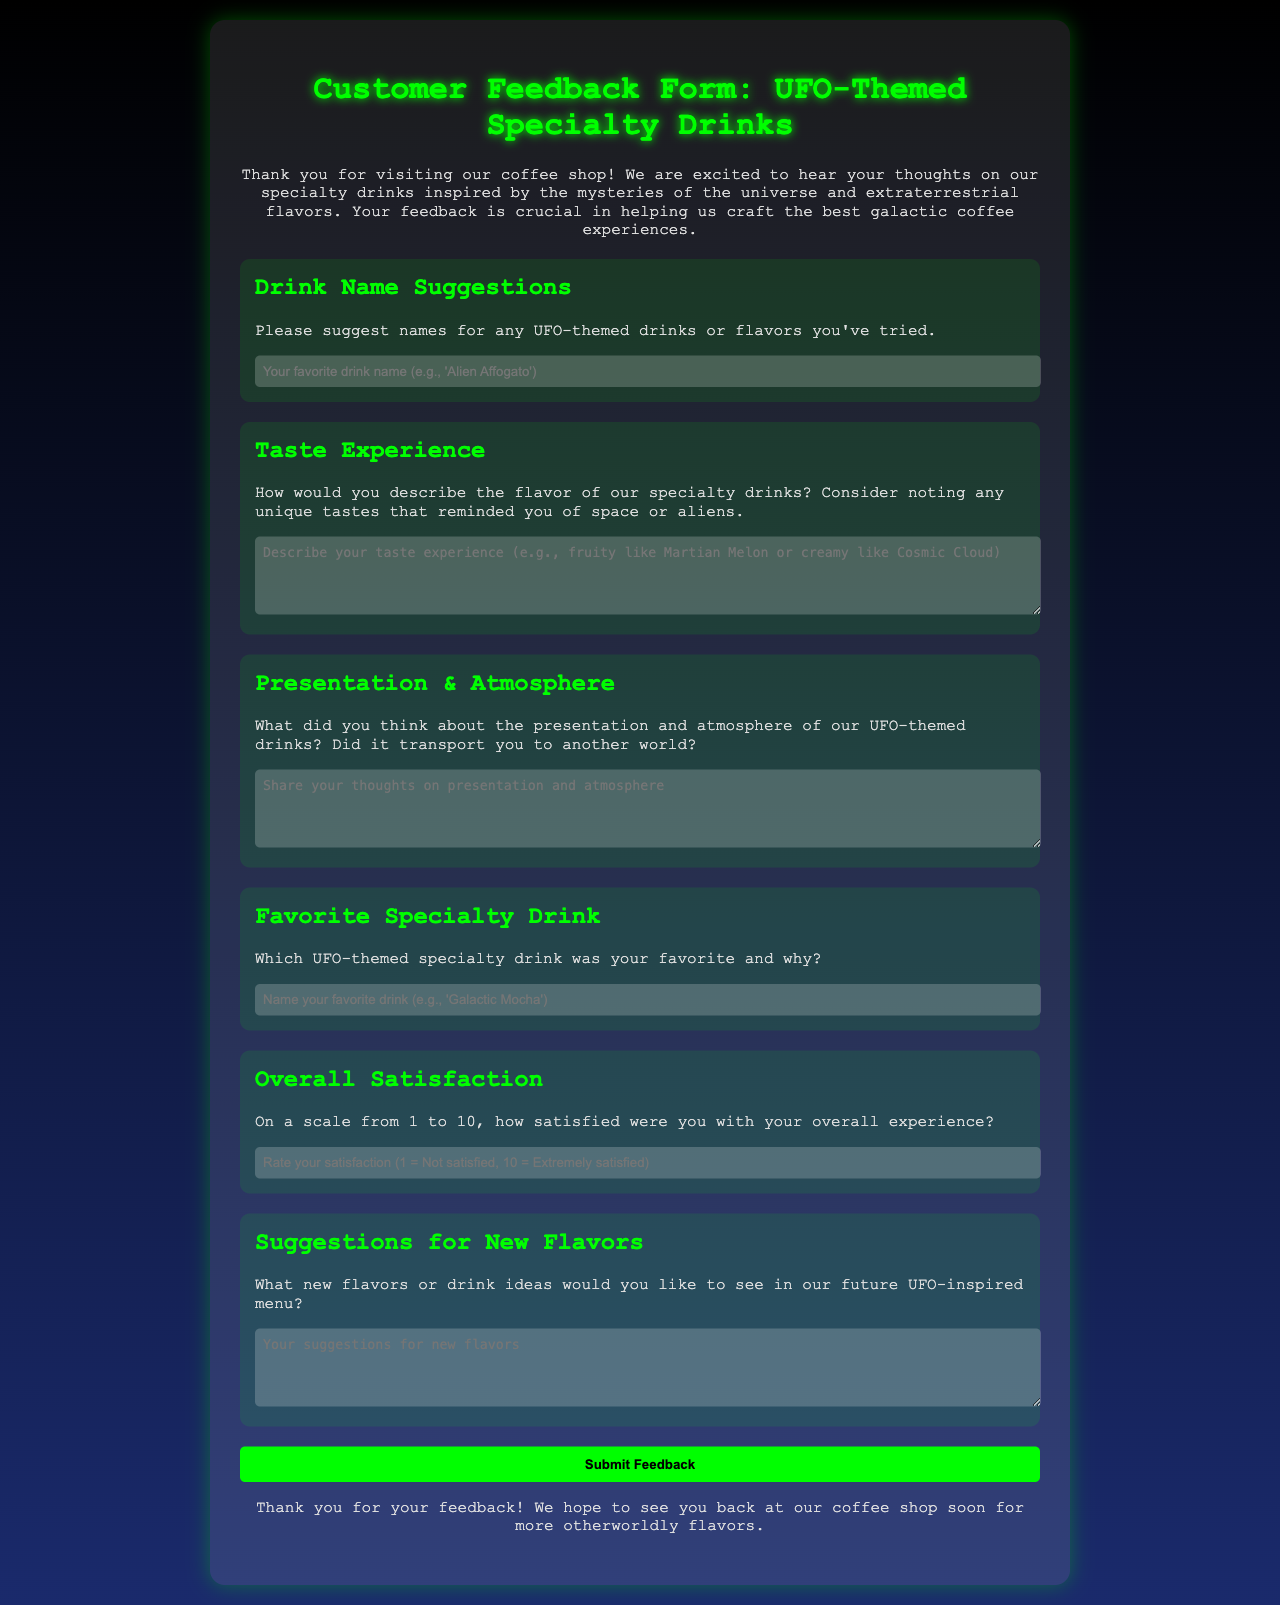what is the title of the feedback form? The title is prominently displayed at the top of the document, indicating the purpose of the form.
Answer: Customer Feedback Form: UFO-Themed Specialty Drinks what does the introduction thank customers for? The introduction expresses gratitude for customers visiting the coffee shop and encourages their feedback.
Answer: visiting our coffee shop how many sections are in the form? By counting the different sections listed in the form, we find that there are six distinct sections.
Answer: 6 what type of drink name should customers suggest? The form specifies that customers should suggest names for UFO-themed drinks or flavors.
Answer: UFO-themed drinks what scale is used for the overall satisfaction rating? The document provides a clear range for satisfaction ratings, from minimum to maximum values.
Answer: 1 to 10 what is the placeholder text for the favorite drink name input? The form guides customers on what to enter by providing an example in the placeholder text.
Answer: Name your favorite drink (e.g., 'Galactic Mocha') what color is used for the submit button? The design of the document specifies the color used for the submit button within the form.
Answer: Green what is the closing statement's tone directed toward customers? The closing statement aims to create a welcoming atmosphere for returning customers.
Answer: welcoming 